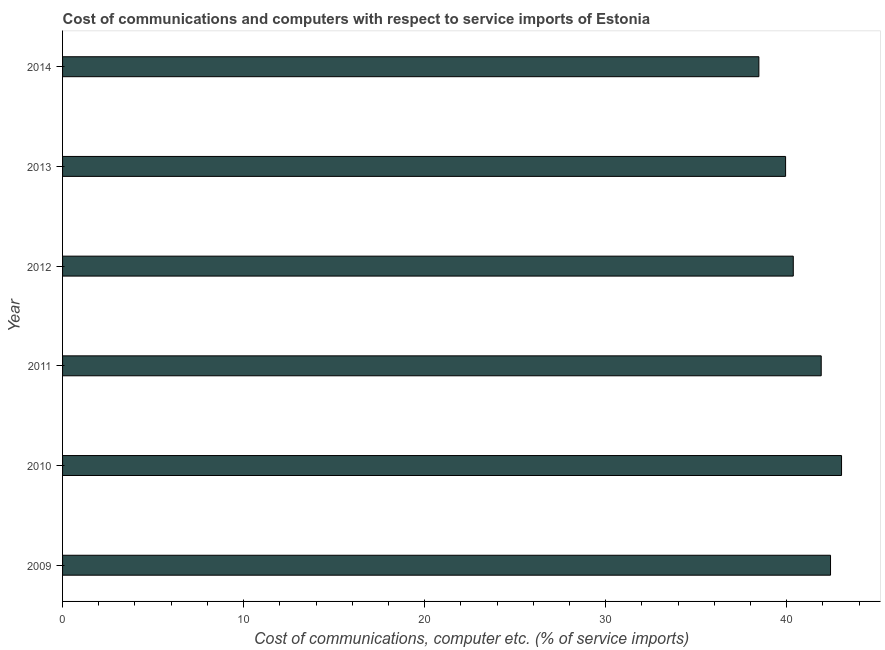What is the title of the graph?
Provide a succinct answer. Cost of communications and computers with respect to service imports of Estonia. What is the label or title of the X-axis?
Ensure brevity in your answer.  Cost of communications, computer etc. (% of service imports). What is the label or title of the Y-axis?
Your response must be concise. Year. What is the cost of communications and computer in 2009?
Give a very brief answer. 42.42. Across all years, what is the maximum cost of communications and computer?
Make the answer very short. 43.03. Across all years, what is the minimum cost of communications and computer?
Offer a very short reply. 38.46. In which year was the cost of communications and computer minimum?
Make the answer very short. 2014. What is the sum of the cost of communications and computer?
Your answer should be compact. 246.13. What is the difference between the cost of communications and computer in 2010 and 2014?
Keep it short and to the point. 4.57. What is the average cost of communications and computer per year?
Your response must be concise. 41.02. What is the median cost of communications and computer?
Your answer should be very brief. 41.14. Do a majority of the years between 2009 and 2012 (inclusive) have cost of communications and computer greater than 42 %?
Provide a short and direct response. No. What is the ratio of the cost of communications and computer in 2010 to that in 2014?
Ensure brevity in your answer.  1.12. Is the cost of communications and computer in 2009 less than that in 2012?
Make the answer very short. No. What is the difference between the highest and the second highest cost of communications and computer?
Your response must be concise. 0.61. What is the difference between the highest and the lowest cost of communications and computer?
Ensure brevity in your answer.  4.57. In how many years, is the cost of communications and computer greater than the average cost of communications and computer taken over all years?
Give a very brief answer. 3. How many bars are there?
Offer a very short reply. 6. How many years are there in the graph?
Your answer should be compact. 6. What is the Cost of communications, computer etc. (% of service imports) of 2009?
Ensure brevity in your answer.  42.42. What is the Cost of communications, computer etc. (% of service imports) of 2010?
Your answer should be very brief. 43.03. What is the Cost of communications, computer etc. (% of service imports) in 2011?
Your answer should be very brief. 41.91. What is the Cost of communications, computer etc. (% of service imports) in 2012?
Keep it short and to the point. 40.37. What is the Cost of communications, computer etc. (% of service imports) of 2013?
Offer a very short reply. 39.94. What is the Cost of communications, computer etc. (% of service imports) in 2014?
Ensure brevity in your answer.  38.46. What is the difference between the Cost of communications, computer etc. (% of service imports) in 2009 and 2010?
Offer a very short reply. -0.61. What is the difference between the Cost of communications, computer etc. (% of service imports) in 2009 and 2011?
Make the answer very short. 0.51. What is the difference between the Cost of communications, computer etc. (% of service imports) in 2009 and 2012?
Keep it short and to the point. 2.06. What is the difference between the Cost of communications, computer etc. (% of service imports) in 2009 and 2013?
Offer a very short reply. 2.48. What is the difference between the Cost of communications, computer etc. (% of service imports) in 2009 and 2014?
Provide a short and direct response. 3.96. What is the difference between the Cost of communications, computer etc. (% of service imports) in 2010 and 2011?
Give a very brief answer. 1.12. What is the difference between the Cost of communications, computer etc. (% of service imports) in 2010 and 2012?
Offer a very short reply. 2.67. What is the difference between the Cost of communications, computer etc. (% of service imports) in 2010 and 2013?
Offer a very short reply. 3.09. What is the difference between the Cost of communications, computer etc. (% of service imports) in 2010 and 2014?
Offer a very short reply. 4.57. What is the difference between the Cost of communications, computer etc. (% of service imports) in 2011 and 2012?
Provide a succinct answer. 1.54. What is the difference between the Cost of communications, computer etc. (% of service imports) in 2011 and 2013?
Offer a terse response. 1.97. What is the difference between the Cost of communications, computer etc. (% of service imports) in 2011 and 2014?
Provide a succinct answer. 3.44. What is the difference between the Cost of communications, computer etc. (% of service imports) in 2012 and 2013?
Keep it short and to the point. 0.42. What is the difference between the Cost of communications, computer etc. (% of service imports) in 2012 and 2014?
Ensure brevity in your answer.  1.9. What is the difference between the Cost of communications, computer etc. (% of service imports) in 2013 and 2014?
Give a very brief answer. 1.48. What is the ratio of the Cost of communications, computer etc. (% of service imports) in 2009 to that in 2010?
Offer a very short reply. 0.99. What is the ratio of the Cost of communications, computer etc. (% of service imports) in 2009 to that in 2012?
Give a very brief answer. 1.05. What is the ratio of the Cost of communications, computer etc. (% of service imports) in 2009 to that in 2013?
Offer a terse response. 1.06. What is the ratio of the Cost of communications, computer etc. (% of service imports) in 2009 to that in 2014?
Your answer should be compact. 1.1. What is the ratio of the Cost of communications, computer etc. (% of service imports) in 2010 to that in 2011?
Keep it short and to the point. 1.03. What is the ratio of the Cost of communications, computer etc. (% of service imports) in 2010 to that in 2012?
Provide a succinct answer. 1.07. What is the ratio of the Cost of communications, computer etc. (% of service imports) in 2010 to that in 2013?
Your answer should be very brief. 1.08. What is the ratio of the Cost of communications, computer etc. (% of service imports) in 2010 to that in 2014?
Offer a terse response. 1.12. What is the ratio of the Cost of communications, computer etc. (% of service imports) in 2011 to that in 2012?
Offer a very short reply. 1.04. What is the ratio of the Cost of communications, computer etc. (% of service imports) in 2011 to that in 2013?
Ensure brevity in your answer.  1.05. What is the ratio of the Cost of communications, computer etc. (% of service imports) in 2011 to that in 2014?
Your answer should be compact. 1.09. What is the ratio of the Cost of communications, computer etc. (% of service imports) in 2012 to that in 2014?
Give a very brief answer. 1.05. What is the ratio of the Cost of communications, computer etc. (% of service imports) in 2013 to that in 2014?
Provide a short and direct response. 1.04. 